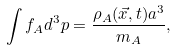Convert formula to latex. <formula><loc_0><loc_0><loc_500><loc_500>\int f _ { A } d ^ { 3 } p = \frac { \rho _ { A } ( \vec { x } , t ) a ^ { 3 } } { m _ { A } } ,</formula> 